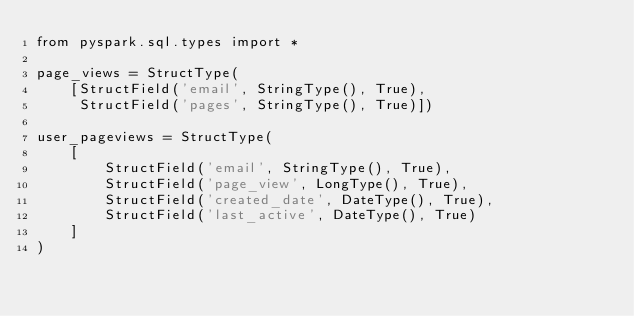Convert code to text. <code><loc_0><loc_0><loc_500><loc_500><_Python_>from pyspark.sql.types import *

page_views = StructType(
    [StructField('email', StringType(), True),
     StructField('pages', StringType(), True)])

user_pageviews = StructType(
    [
        StructField('email', StringType(), True),
        StructField('page_view', LongType(), True),
        StructField('created_date', DateType(), True),
        StructField('last_active', DateType(), True)
    ]
)



</code> 